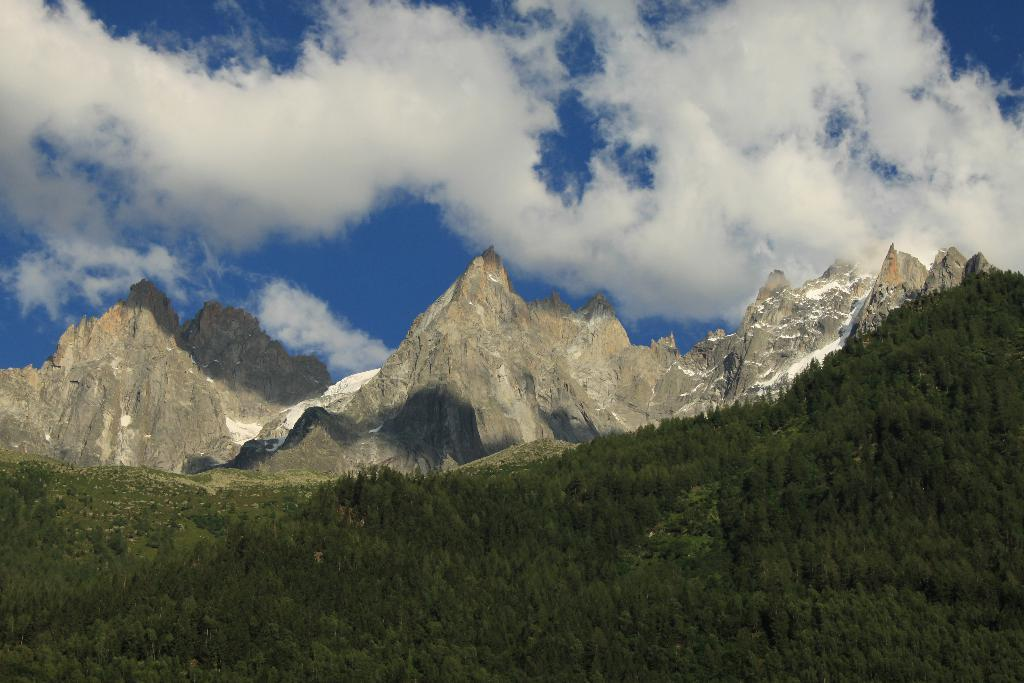What type of vegetation can be seen in the image? There are trees in the image. What geographical feature is visible in the image? There are mountains in the image. What type of ground cover is present in the image? There is grass in the image. What can be seen in the background of the image? The sky is visible in the background of the image. What is the condition of the sky in the image? Clouds are present in the sky. Who is the owner of the trees in the image? There is no information about the ownership of the trees in the image. Can you tell me the name of the sister of the boy in the image? There is no boy or sister present in the image. 